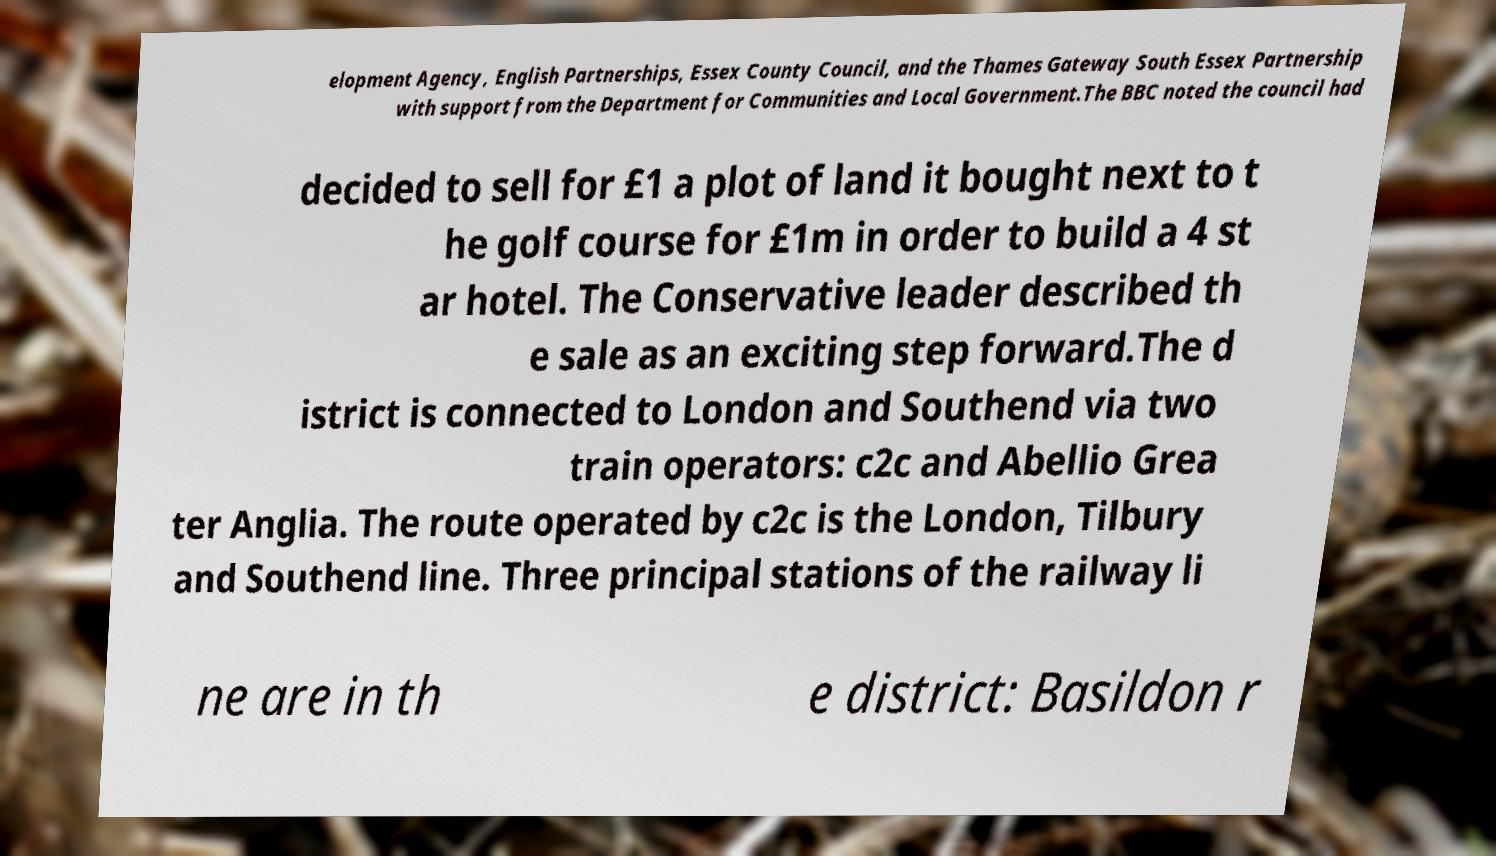Please read and relay the text visible in this image. What does it say? elopment Agency, English Partnerships, Essex County Council, and the Thames Gateway South Essex Partnership with support from the Department for Communities and Local Government.The BBC noted the council had decided to sell for £1 a plot of land it bought next to t he golf course for £1m in order to build a 4 st ar hotel. The Conservative leader described th e sale as an exciting step forward.The d istrict is connected to London and Southend via two train operators: c2c and Abellio Grea ter Anglia. The route operated by c2c is the London, Tilbury and Southend line. Three principal stations of the railway li ne are in th e district: Basildon r 